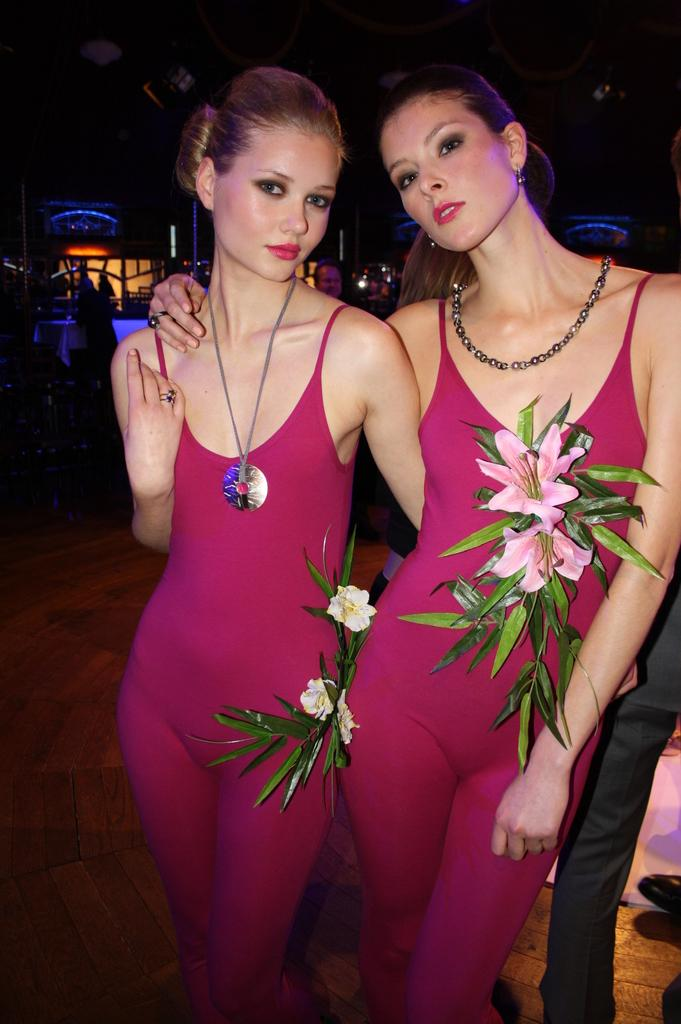How many people are in the image? There are two persons in the image. Where is the person on the right side of the image located? The person on the right side is standing on the right side of the image. What is the person on the right side wearing? The person on the right side is wearing a pink dress. What structure can be seen on the left side of the image? There is a house in the image, located on the left side. What type of steel is used in the construction of the house in the image? There is no mention of steel or any construction materials in the image; it only shows a house and two persons. 